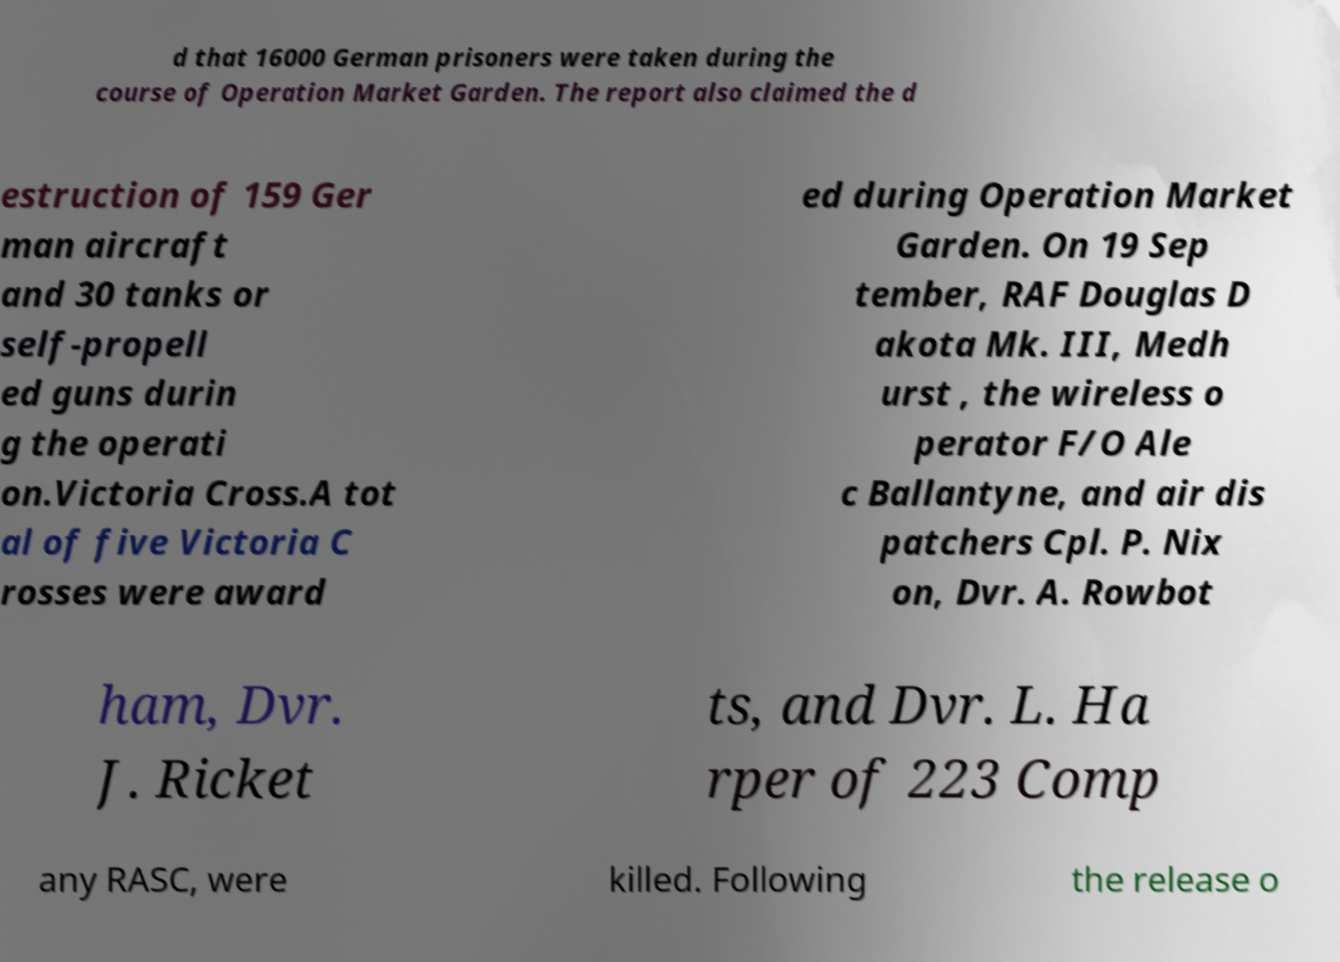What messages or text are displayed in this image? I need them in a readable, typed format. d that 16000 German prisoners were taken during the course of Operation Market Garden. The report also claimed the d estruction of 159 Ger man aircraft and 30 tanks or self-propell ed guns durin g the operati on.Victoria Cross.A tot al of five Victoria C rosses were award ed during Operation Market Garden. On 19 Sep tember, RAF Douglas D akota Mk. III, Medh urst , the wireless o perator F/O Ale c Ballantyne, and air dis patchers Cpl. P. Nix on, Dvr. A. Rowbot ham, Dvr. J. Ricket ts, and Dvr. L. Ha rper of 223 Comp any RASC, were killed. Following the release o 